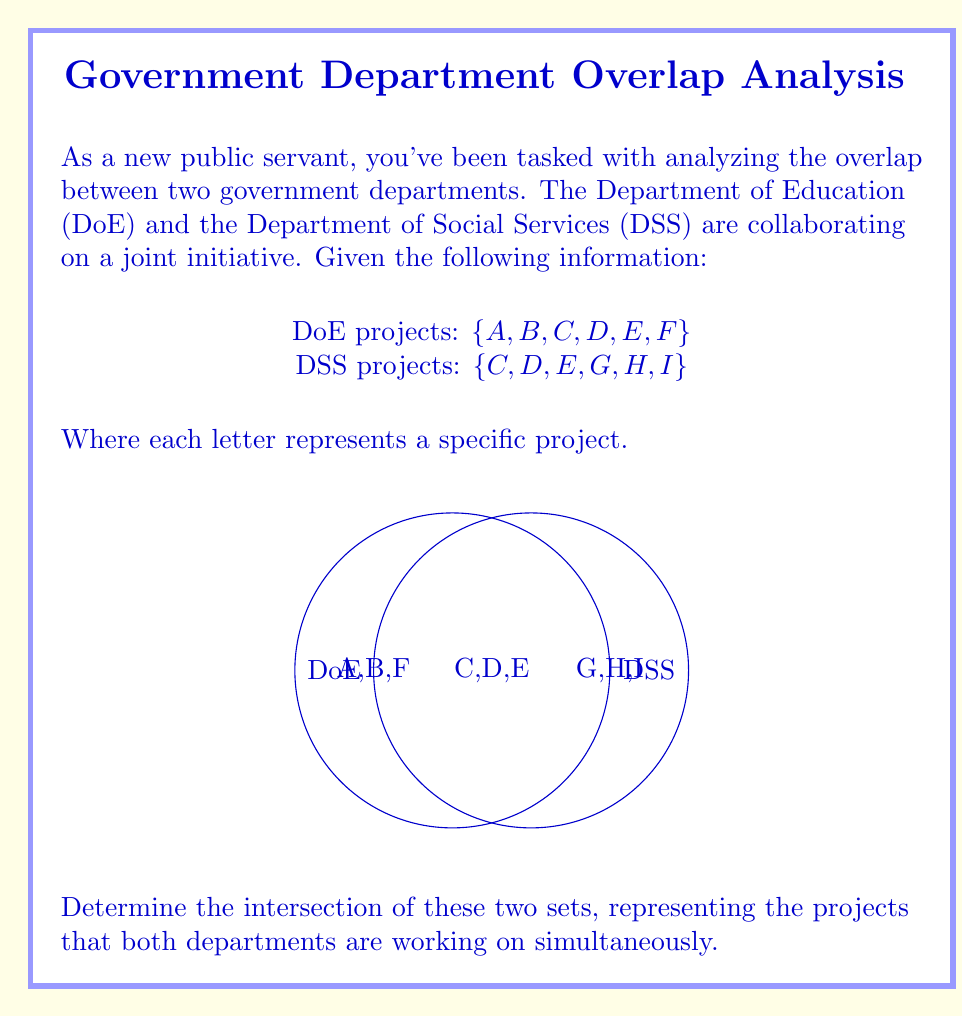Give your solution to this math problem. To find the intersection of two sets, we need to identify the elements that are common to both sets. Let's approach this step-by-step:

1) First, let's write out our sets:
   DoE = $\{A, B, C, D, E, F\}$
   DSS = $\{C, D, E, G, H, I\}$

2) The intersection of these sets, denoted as DoE $\cap$ DSS, will contain all elements that appear in both sets.

3) Comparing the elements:
   - A, B, F are only in DoE
   - G, H, I are only in DSS
   - C, D, E appear in both sets

4) Therefore, the elements in the intersection are C, D, and E.

5) We can write this mathematically as:
   DoE $\cap$ DSS = $\{C, D, E\}$

This result shows the projects that both departments are working on simultaneously, which is crucial information for coordinating the joint initiative.
Answer: $\{C, D, E\}$ 